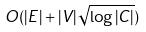Convert formula to latex. <formula><loc_0><loc_0><loc_500><loc_500>O ( | E | + | V | \sqrt { \log | C | } )</formula> 